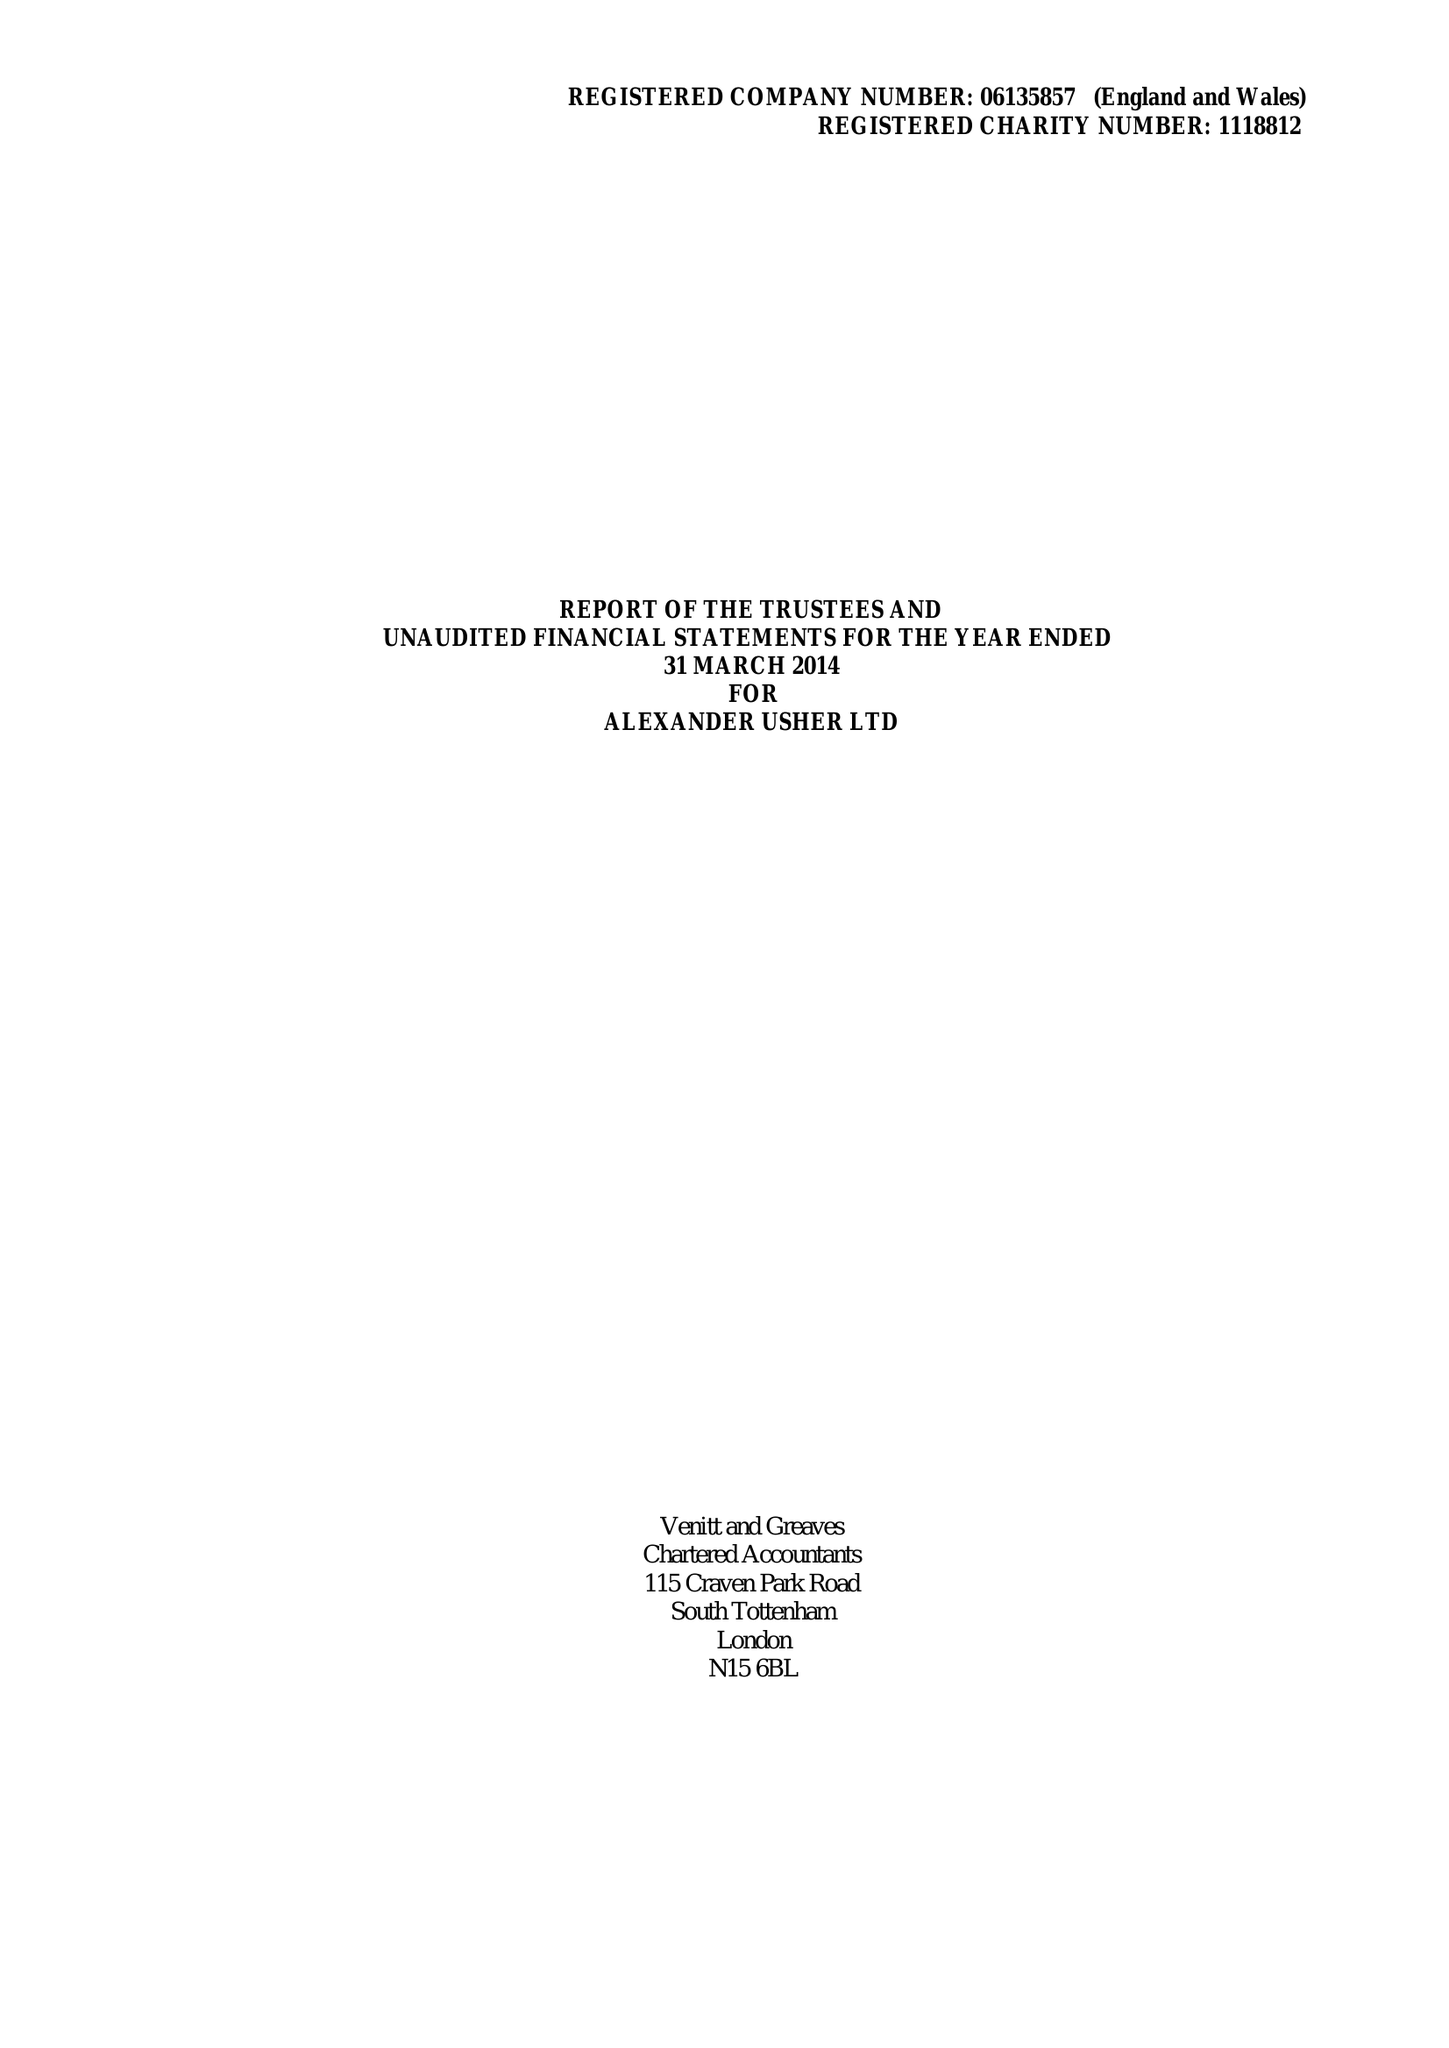What is the value for the report_date?
Answer the question using a single word or phrase. 2014-03-31 